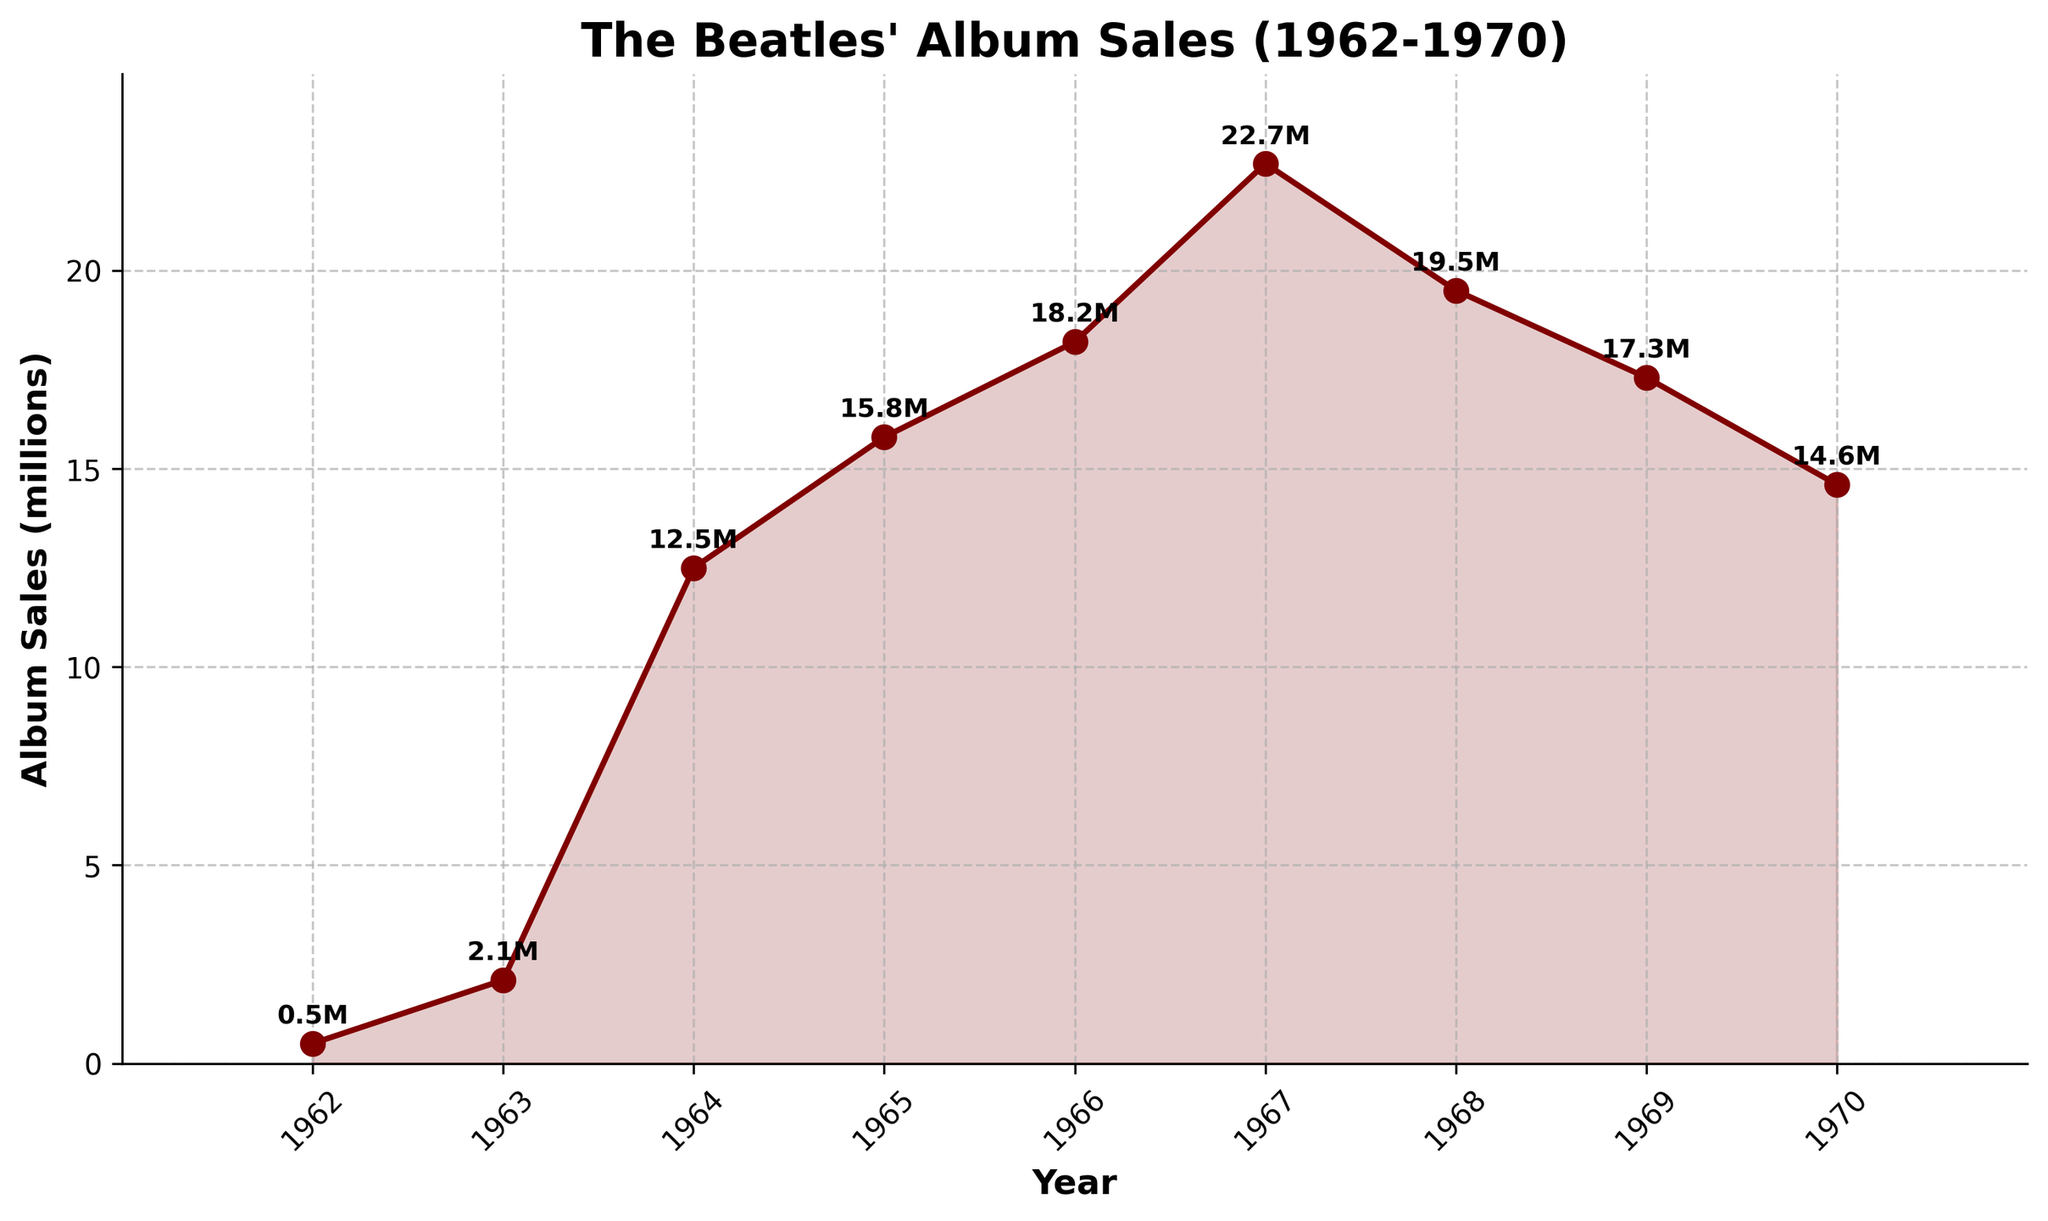which year had the highest album sales? Looking at the figure, the highest point on the plot represents the year with the highest album sales. The peak sales figure is 22.7 million, occurring in 1967.
Answer: 1967 what was the difference in album sales between 1964 and 1967? Refer to the plotted data points for 1964 and 1967. The album sales in 1964 were 12.5 million, and in 1967 it was 22.7 million. The difference is 22.7 - 12.5 = 10.2 million.
Answer: 10.2 million which year experienced the largest increase in album sales compared to the previous year? Examine the steepness of the line between each consecutive pair of years. The segment from 1963 to 1964 shows the highest increase, from 2.1 million to 12.5 million - an increase of 10.4 million.
Answer: 1964 how many years had album sales of more than 15 million? Identify data points above 15 million. These occur in the years 1965 to 1968. Count the years: 1965, 1966, 1967, 1968, which makes 4 years.
Answer: 4 years what is the average album sales over the years 1962 to 1970? Sum the sales values for each year and divide by the number of years. The sum is 0.5 + 2.1 + 12.5 + 15.8 + 18.2 + 22.7 + 19.5 + 17.3 + 14.6 = 123.2 million. Divide by the 9 years: 123.2 / 9 = 13.69 million.
Answer: 13.69 million between which two consecutive years did the album sales drop the most? Identify the steepest drop on the chart by examining descending segments. The drop from 1968 to 1969 is the largest, falling from 19.5 million to 17.3 million - a decrease of 2.2 million.
Answer: 1968 to 1969 what is the total album sales from 1962 to 1965? Sum the album sales from 1962 to 1965: 0.5 + 2.1 + 12.5 + 15.8 = 30.9 million.
Answer: 30.9 million how did the album sales in 1970 compare to those in 1966? Compare the values of 1970 and 1966. Sales in 1970 were 14.6 million, and in 1966 they were 18.2 million. 1970 sales are less than those of 1966 by 18.2 - 14.6 = 3.6 million.
Answer: 3.6 million what trend can be observed in album sales from 1962 to 1967? Examine the plotted line from 1962 to 1967. There is a consistent upward trend, indicating increasing sales each year during this period.
Answer: consistent increase 